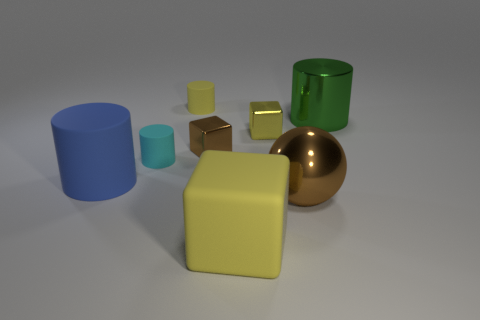What is the size of the brown shiny cube that is left of the green shiny thing that is to the right of the small object that is behind the green object?
Give a very brief answer. Small. Is there anything else that has the same color as the large matte cylinder?
Keep it short and to the point. No. There is a big cylinder that is to the left of the brown metal object left of the yellow matte thing in front of the blue cylinder; what is it made of?
Make the answer very short. Rubber. Is the shape of the tiny brown shiny object the same as the large green thing?
Make the answer very short. No. How many big things are in front of the blue thing and left of the brown shiny ball?
Your answer should be very brief. 1. The big rubber cylinder that is to the left of the tiny thing that is on the right side of the big yellow rubber object is what color?
Provide a short and direct response. Blue. Are there an equal number of large metallic things in front of the big block and small cyan matte things?
Your answer should be very brief. No. How many blue cylinders are behind the tiny cylinder that is behind the brown object that is behind the large brown object?
Keep it short and to the point. 0. There is a large matte thing on the left side of the matte cube; what is its color?
Ensure brevity in your answer.  Blue. There is a big thing that is both on the right side of the tiny yellow block and in front of the blue thing; what material is it made of?
Offer a very short reply. Metal. 